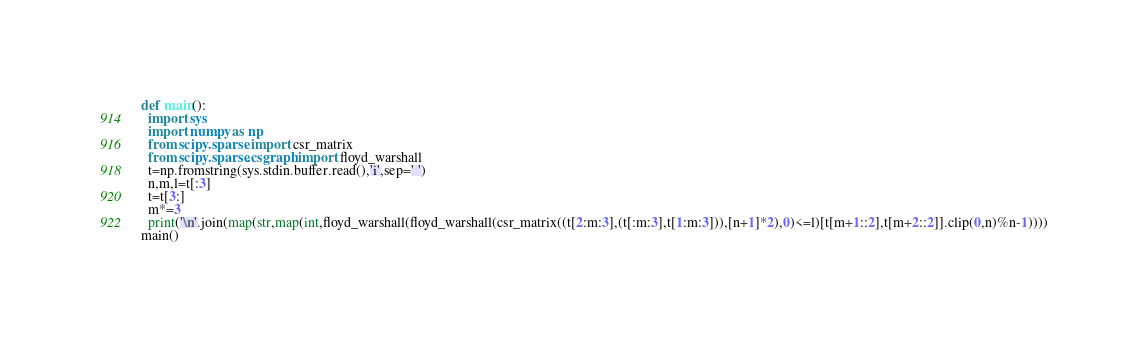<code> <loc_0><loc_0><loc_500><loc_500><_Python_>def main():
  import sys
  import numpy as np
  from scipy.sparse import csr_matrix
  from scipy.sparse.csgraph import floyd_warshall
  t=np.fromstring(sys.stdin.buffer.read(),'i',sep=' ')
  n,m,l=t[:3]
  t=t[3:]
  m*=3
  print('\n'.join(map(str,map(int,floyd_warshall(floyd_warshall(csr_matrix((t[2:m:3],(t[:m:3],t[1:m:3])),[n+1]*2),0)<=l)[t[m+1::2],t[m+2::2]].clip(0,n)%n-1))))
main()</code> 